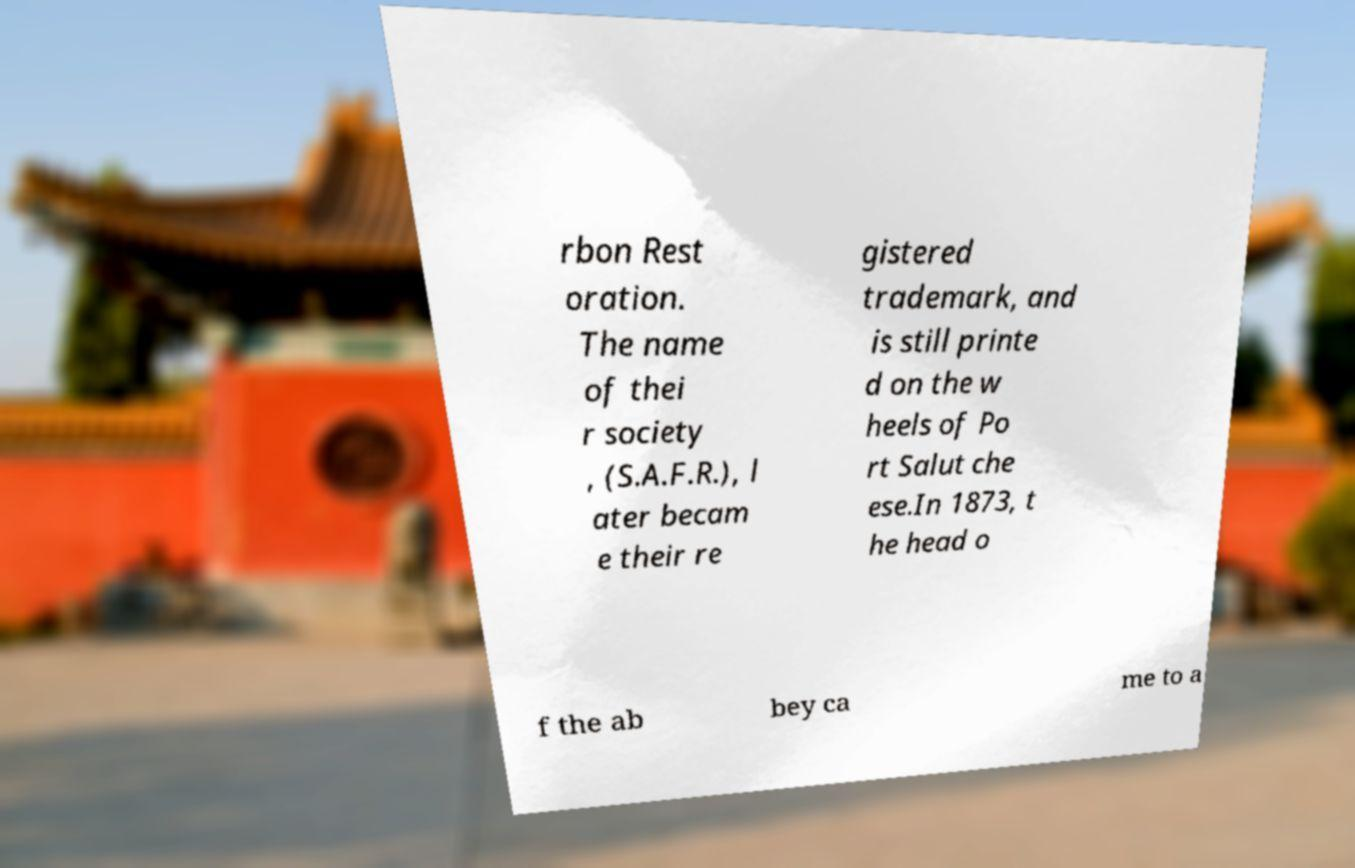Could you assist in decoding the text presented in this image and type it out clearly? rbon Rest oration. The name of thei r society , (S.A.F.R.), l ater becam e their re gistered trademark, and is still printe d on the w heels of Po rt Salut che ese.In 1873, t he head o f the ab bey ca me to a 